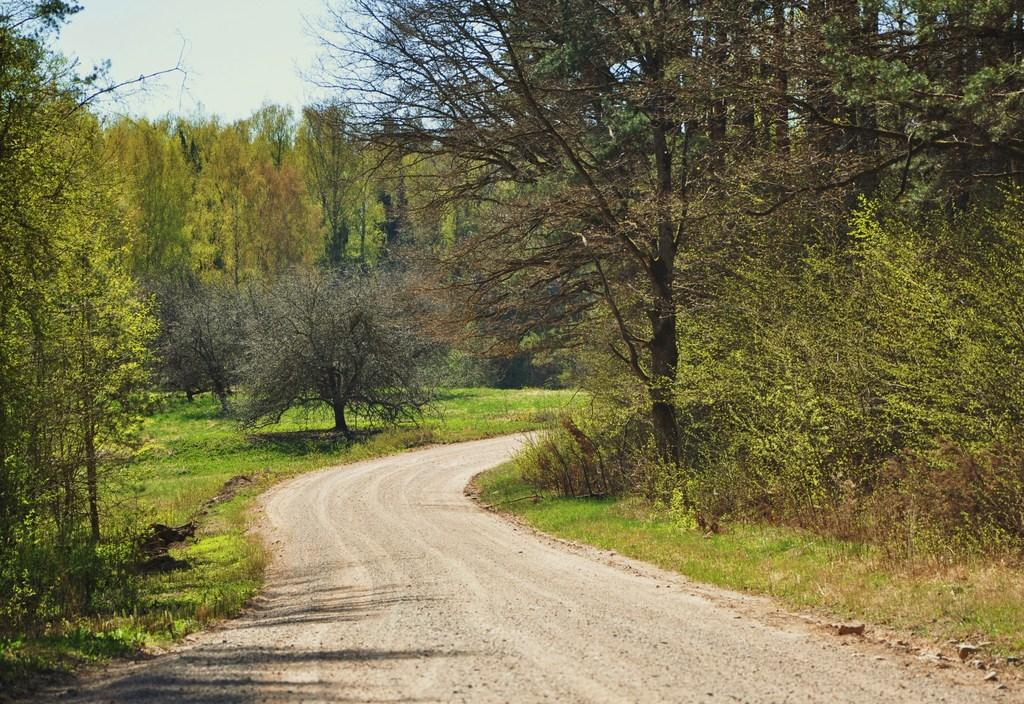What type of vegetation can be seen in the image? There is grass in the image. What other natural elements are present in the image? There are trees in the image. What part of the natural environment is visible in the image? The sky is visible in the image. What type of machine is being used to apply paste to the trees in the image? There is no machine or paste present in the image; it features grass, trees, and the sky. How many toes can be seen on the grass in the image? There are no toes visible in the image, as it features natural elements like grass, trees, and the sky. 